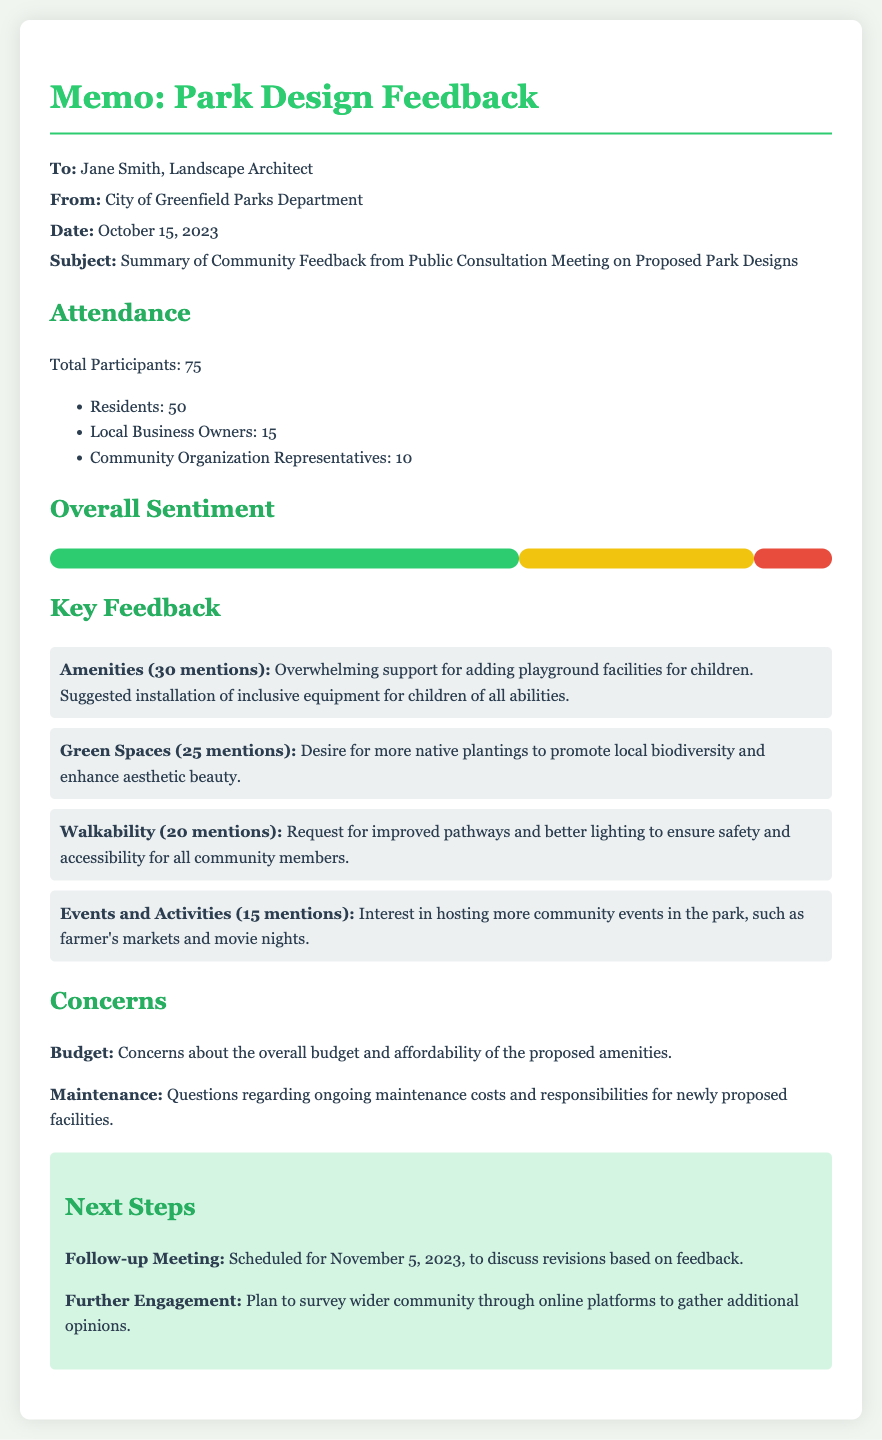What is the date of the memo? The date of the memo is explicitly mentioned in the document as October 15, 2023.
Answer: October 15, 2023 How many total participants attended the meeting? The total number of participants is specified in the document under the Attendance section, which states 'Total Participants: 75'.
Answer: 75 What percentage of feedback was positive? The percentage of positive feedback is given visually in the chart, stating 'Positive: 60%'.
Answer: 60% What concern was raised regarding budget? The document mentions concerns about the overall budget specifically in the Concerns section.
Answer: Overall budget What was the top mention in the Key Feedback section? The most mentioned feedback category is 'Amenities', which received 30 mentions as stated in the Key Feedback section.
Answer: Amenities What type of events are community members interested in hosting? The specific type of events mentioned in the feedback include farmer's markets and movie nights as noted in the Events and Activities feedback item.
Answer: Farmer's markets and movie nights When is the follow-up meeting scheduled? The follow-up meeting date is included in the Next Steps section of the memo, stating 'Scheduled for November 5, 2023'.
Answer: November 5, 2023 How many mentions were there for improved pathways? The document lists mentions regarding pathways under Walkability, which received 20 mentions.
Answer: 20 What is planned for further engagement with the community? Further engagement plans include surveying the wider community through online platforms as outlined in the Next Steps section.
Answer: Surveying wider community through online platforms 